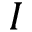Convert formula to latex. <formula><loc_0><loc_0><loc_500><loc_500>I</formula> 